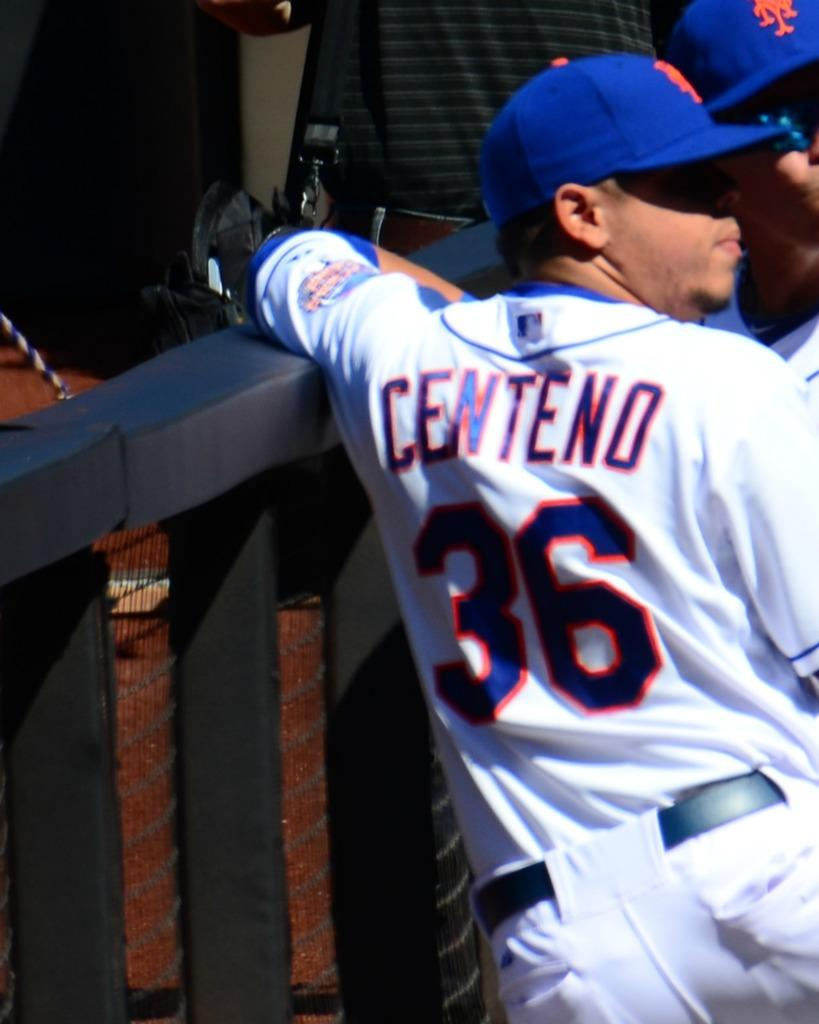<image>
Write a terse but informative summary of the picture. A man with a baseball uniform that has the name Centeno. 